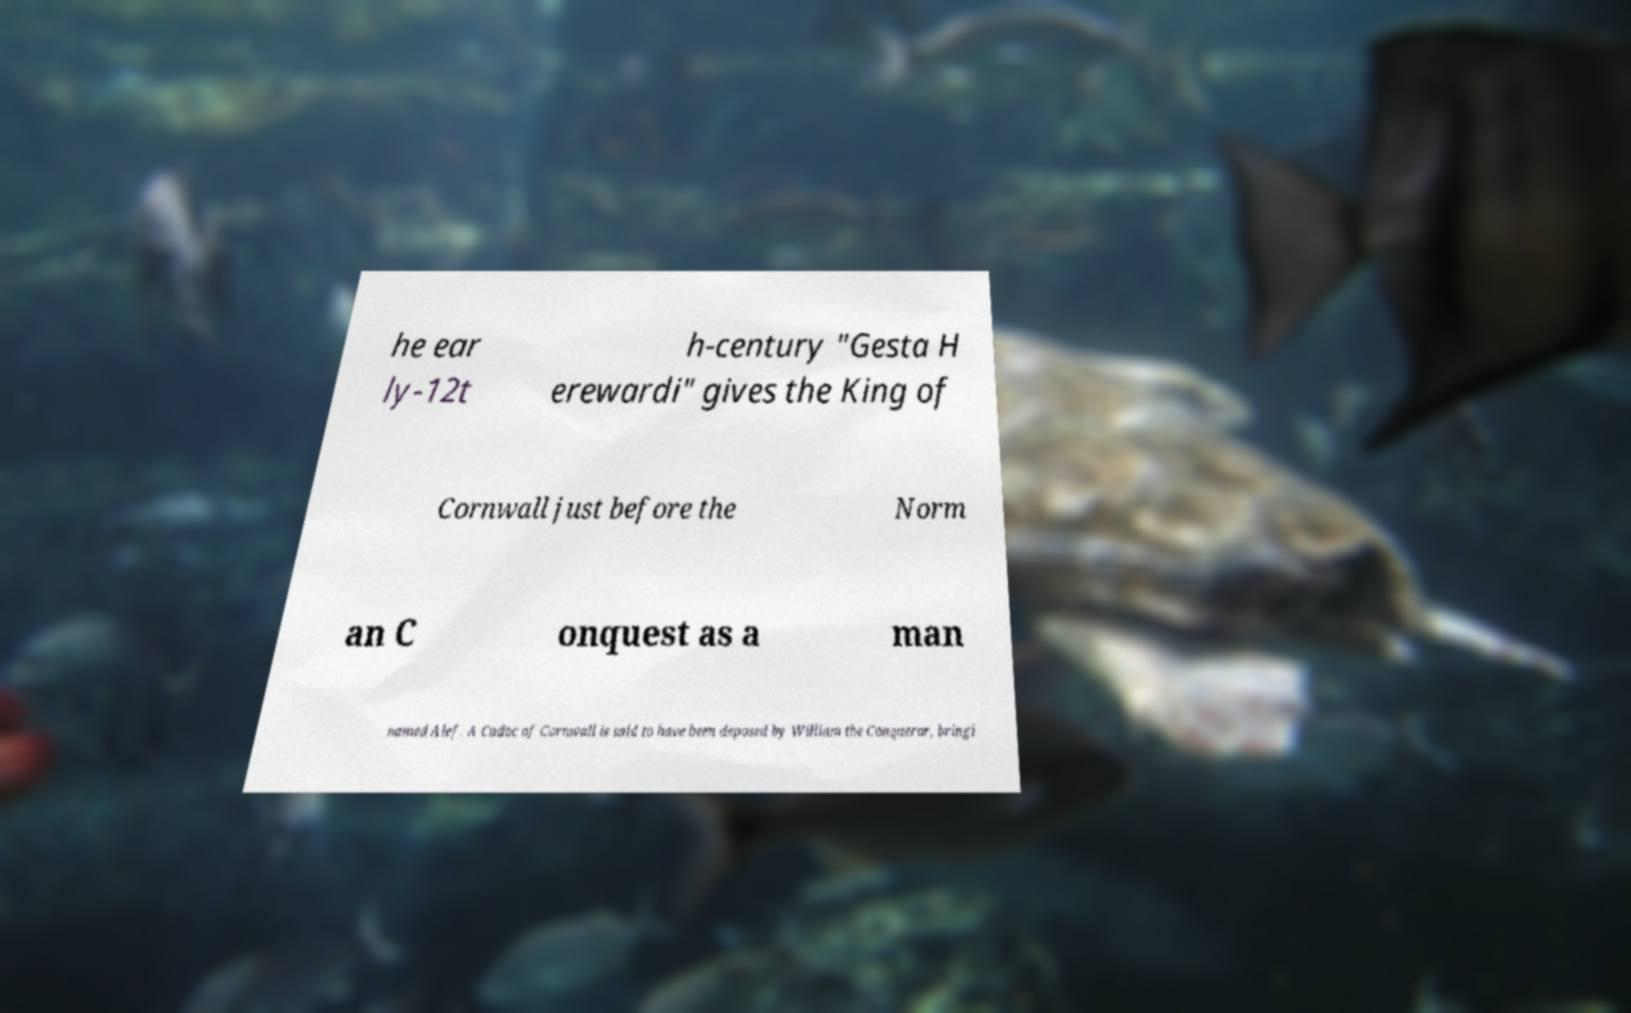Could you assist in decoding the text presented in this image and type it out clearly? he ear ly-12t h-century "Gesta H erewardi" gives the King of Cornwall just before the Norm an C onquest as a man named Alef. A Cadoc of Cornwall is said to have been deposed by William the Conqueror, bringi 